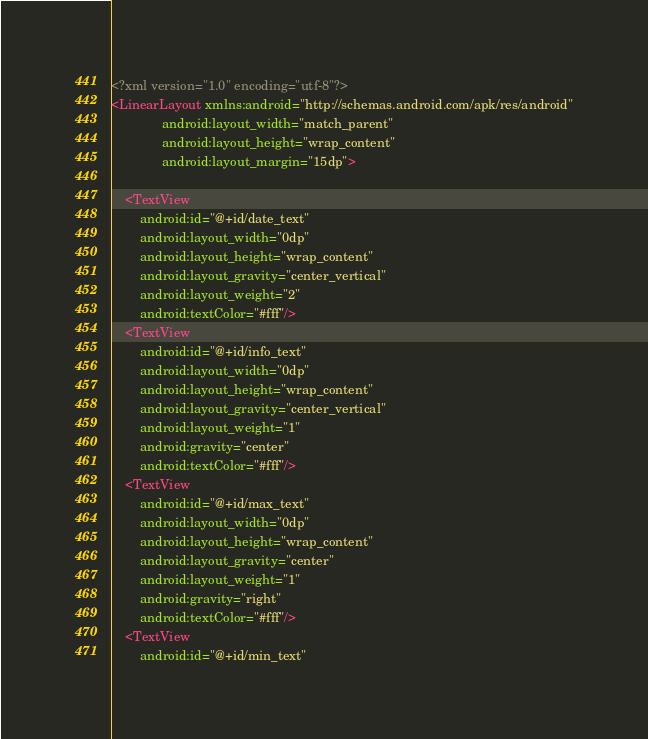Convert code to text. <code><loc_0><loc_0><loc_500><loc_500><_XML_><?xml version="1.0" encoding="utf-8"?>
<LinearLayout xmlns:android="http://schemas.android.com/apk/res/android"
              android:layout_width="match_parent"
              android:layout_height="wrap_content"
              android:layout_margin="15dp">

    <TextView
        android:id="@+id/date_text"
        android:layout_width="0dp"
        android:layout_height="wrap_content"
        android:layout_gravity="center_vertical"
        android:layout_weight="2"
        android:textColor="#fff"/>
    <TextView
        android:id="@+id/info_text"
        android:layout_width="0dp"
        android:layout_height="wrap_content"
        android:layout_gravity="center_vertical"
        android:layout_weight="1"
        android:gravity="center"
        android:textColor="#fff"/>
    <TextView
        android:id="@+id/max_text"
        android:layout_width="0dp"
        android:layout_height="wrap_content"
        android:layout_gravity="center"
        android:layout_weight="1"
        android:gravity="right"
        android:textColor="#fff"/>
    <TextView
        android:id="@+id/min_text"</code> 